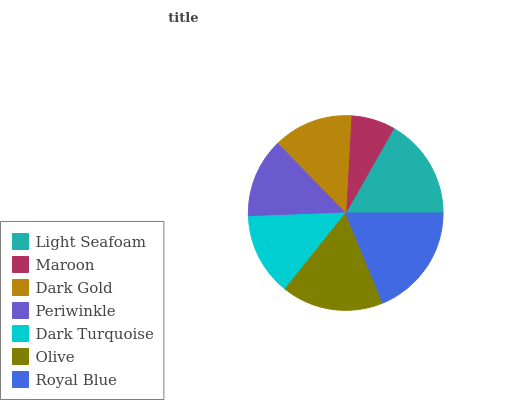Is Maroon the minimum?
Answer yes or no. Yes. Is Royal Blue the maximum?
Answer yes or no. Yes. Is Dark Gold the minimum?
Answer yes or no. No. Is Dark Gold the maximum?
Answer yes or no. No. Is Dark Gold greater than Maroon?
Answer yes or no. Yes. Is Maroon less than Dark Gold?
Answer yes or no. Yes. Is Maroon greater than Dark Gold?
Answer yes or no. No. Is Dark Gold less than Maroon?
Answer yes or no. No. Is Dark Turquoise the high median?
Answer yes or no. Yes. Is Dark Turquoise the low median?
Answer yes or no. Yes. Is Maroon the high median?
Answer yes or no. No. Is Olive the low median?
Answer yes or no. No. 